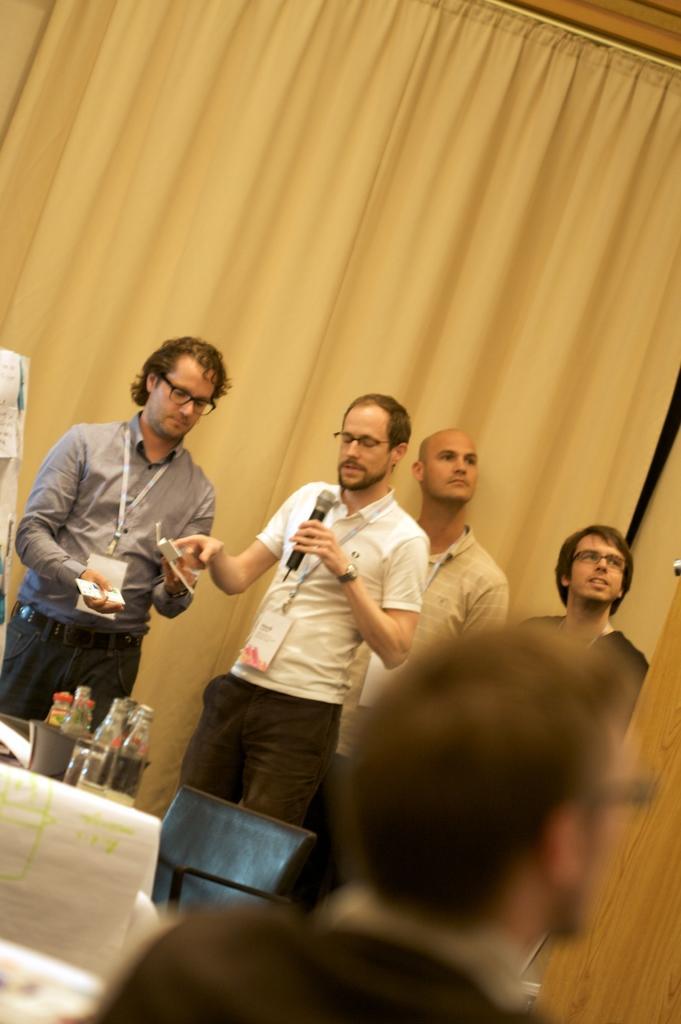Could you give a brief overview of what you see in this image? In this picture there are some persons standing in front and speaking something on the microphone. In the front bottom side there is a man sitting on the chair and looking on the right side. Behind there is a white curtain. 